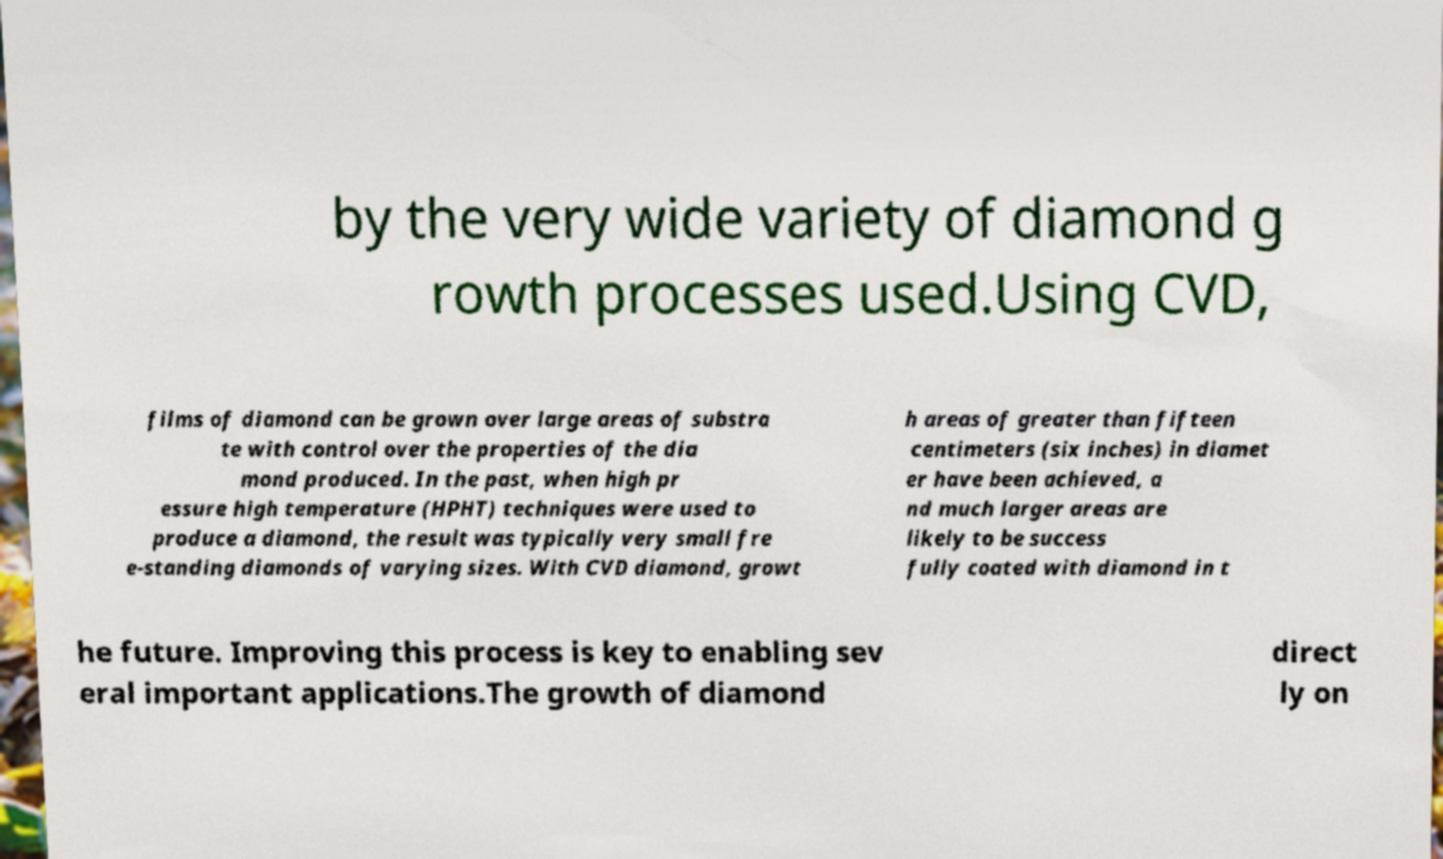There's text embedded in this image that I need extracted. Can you transcribe it verbatim? by the very wide variety of diamond g rowth processes used.Using CVD, films of diamond can be grown over large areas of substra te with control over the properties of the dia mond produced. In the past, when high pr essure high temperature (HPHT) techniques were used to produce a diamond, the result was typically very small fre e-standing diamonds of varying sizes. With CVD diamond, growt h areas of greater than fifteen centimeters (six inches) in diamet er have been achieved, a nd much larger areas are likely to be success fully coated with diamond in t he future. Improving this process is key to enabling sev eral important applications.The growth of diamond direct ly on 